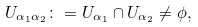<formula> <loc_0><loc_0><loc_500><loc_500>U _ { \alpha _ { 1 } \alpha _ { 2 } } \colon = U _ { \alpha _ { 1 } } \cap U _ { \alpha _ { 2 } } \neq \phi ,</formula> 